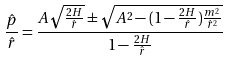Convert formula to latex. <formula><loc_0><loc_0><loc_500><loc_500>\frac { \hat { p } } { \hat { r } } = \frac { A \sqrt { \frac { 2 H } { \hat { r } } } \pm \sqrt { A ^ { 2 } - ( 1 - \frac { 2 H } { \hat { r } } ) \frac { m ^ { 2 } } { \hat { r } ^ { 2 } } } } { 1 - \frac { 2 H } { \hat { r } } }</formula> 